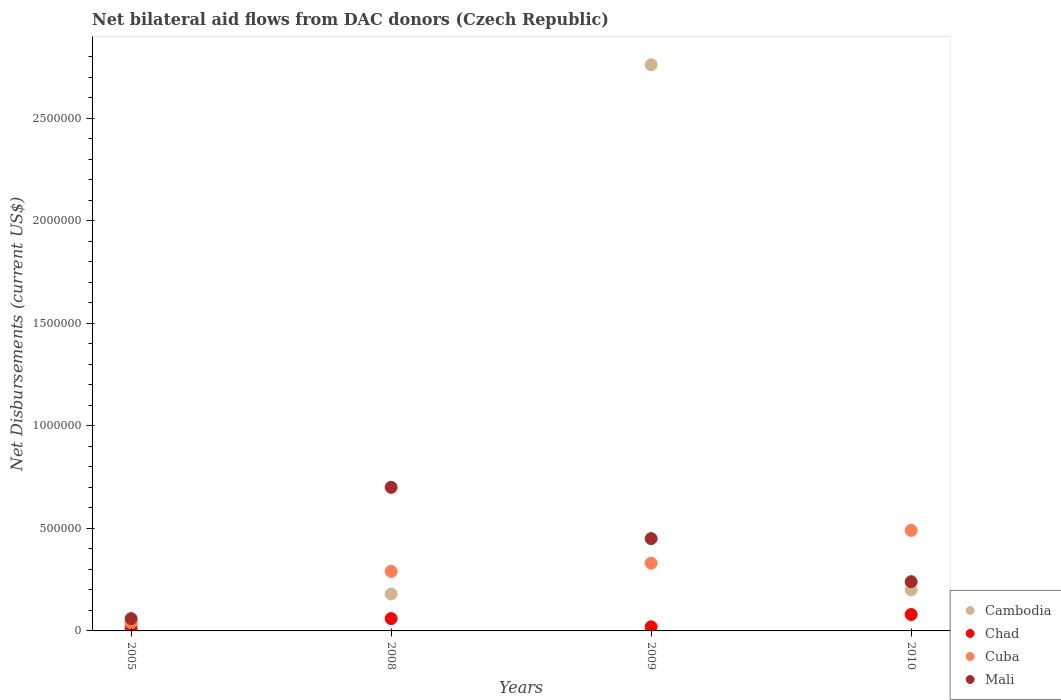Is the number of dotlines equal to the number of legend labels?
Ensure brevity in your answer.  Yes. What is the net bilateral aid flows in Mali in 2009?
Provide a short and direct response. 4.50e+05. Across all years, what is the maximum net bilateral aid flows in Cambodia?
Offer a very short reply. 2.76e+06. Across all years, what is the minimum net bilateral aid flows in Cuba?
Give a very brief answer. 4.00e+04. In which year was the net bilateral aid flows in Cambodia maximum?
Offer a very short reply. 2009. What is the total net bilateral aid flows in Chad in the graph?
Offer a terse response. 1.70e+05. What is the difference between the net bilateral aid flows in Cambodia in 2005 and that in 2009?
Provide a succinct answer. -2.73e+06. What is the difference between the net bilateral aid flows in Cuba in 2005 and the net bilateral aid flows in Cambodia in 2008?
Your response must be concise. -1.40e+05. What is the average net bilateral aid flows in Mali per year?
Offer a terse response. 3.62e+05. In the year 2005, what is the difference between the net bilateral aid flows in Chad and net bilateral aid flows in Cuba?
Provide a short and direct response. -3.00e+04. In how many years, is the net bilateral aid flows in Chad greater than 2400000 US$?
Offer a very short reply. 0. What is the ratio of the net bilateral aid flows in Chad in 2005 to that in 2008?
Give a very brief answer. 0.17. Is the net bilateral aid flows in Mali in 2005 less than that in 2009?
Your answer should be compact. Yes. Is the difference between the net bilateral aid flows in Chad in 2005 and 2010 greater than the difference between the net bilateral aid flows in Cuba in 2005 and 2010?
Offer a very short reply. Yes. What is the difference between the highest and the second highest net bilateral aid flows in Cambodia?
Provide a succinct answer. 2.56e+06. Is it the case that in every year, the sum of the net bilateral aid flows in Mali and net bilateral aid flows in Cambodia  is greater than the sum of net bilateral aid flows in Chad and net bilateral aid flows in Cuba?
Your answer should be compact. No. Does the net bilateral aid flows in Cuba monotonically increase over the years?
Give a very brief answer. Yes. Is the net bilateral aid flows in Chad strictly greater than the net bilateral aid flows in Cuba over the years?
Offer a terse response. No. How many dotlines are there?
Your response must be concise. 4. What is the difference between two consecutive major ticks on the Y-axis?
Ensure brevity in your answer.  5.00e+05. Are the values on the major ticks of Y-axis written in scientific E-notation?
Give a very brief answer. No. Does the graph contain any zero values?
Your answer should be compact. No. Where does the legend appear in the graph?
Your answer should be compact. Bottom right. How many legend labels are there?
Your answer should be very brief. 4. How are the legend labels stacked?
Give a very brief answer. Vertical. What is the title of the graph?
Ensure brevity in your answer.  Net bilateral aid flows from DAC donors (Czech Republic). Does "Argentina" appear as one of the legend labels in the graph?
Give a very brief answer. No. What is the label or title of the Y-axis?
Make the answer very short. Net Disbursements (current US$). What is the Net Disbursements (current US$) in Cambodia in 2005?
Keep it short and to the point. 3.00e+04. What is the Net Disbursements (current US$) in Cuba in 2005?
Give a very brief answer. 4.00e+04. What is the Net Disbursements (current US$) of Cambodia in 2008?
Your answer should be compact. 1.80e+05. What is the Net Disbursements (current US$) of Cambodia in 2009?
Your response must be concise. 2.76e+06. What is the Net Disbursements (current US$) of Chad in 2009?
Your response must be concise. 2.00e+04. What is the Net Disbursements (current US$) of Mali in 2009?
Your answer should be very brief. 4.50e+05. What is the Net Disbursements (current US$) in Cambodia in 2010?
Your answer should be compact. 2.00e+05. What is the Net Disbursements (current US$) in Chad in 2010?
Provide a short and direct response. 8.00e+04. What is the Net Disbursements (current US$) in Cuba in 2010?
Ensure brevity in your answer.  4.90e+05. What is the Net Disbursements (current US$) in Mali in 2010?
Offer a terse response. 2.40e+05. Across all years, what is the maximum Net Disbursements (current US$) in Cambodia?
Offer a very short reply. 2.76e+06. Across all years, what is the maximum Net Disbursements (current US$) of Cuba?
Keep it short and to the point. 4.90e+05. Across all years, what is the maximum Net Disbursements (current US$) in Mali?
Provide a succinct answer. 7.00e+05. Across all years, what is the minimum Net Disbursements (current US$) of Cuba?
Your answer should be compact. 4.00e+04. Across all years, what is the minimum Net Disbursements (current US$) of Mali?
Keep it short and to the point. 6.00e+04. What is the total Net Disbursements (current US$) in Cambodia in the graph?
Give a very brief answer. 3.17e+06. What is the total Net Disbursements (current US$) of Chad in the graph?
Your response must be concise. 1.70e+05. What is the total Net Disbursements (current US$) of Cuba in the graph?
Your response must be concise. 1.15e+06. What is the total Net Disbursements (current US$) in Mali in the graph?
Your response must be concise. 1.45e+06. What is the difference between the Net Disbursements (current US$) of Cambodia in 2005 and that in 2008?
Give a very brief answer. -1.50e+05. What is the difference between the Net Disbursements (current US$) of Chad in 2005 and that in 2008?
Make the answer very short. -5.00e+04. What is the difference between the Net Disbursements (current US$) in Cuba in 2005 and that in 2008?
Make the answer very short. -2.50e+05. What is the difference between the Net Disbursements (current US$) in Mali in 2005 and that in 2008?
Your answer should be very brief. -6.40e+05. What is the difference between the Net Disbursements (current US$) in Cambodia in 2005 and that in 2009?
Offer a very short reply. -2.73e+06. What is the difference between the Net Disbursements (current US$) of Cuba in 2005 and that in 2009?
Your answer should be compact. -2.90e+05. What is the difference between the Net Disbursements (current US$) in Mali in 2005 and that in 2009?
Make the answer very short. -3.90e+05. What is the difference between the Net Disbursements (current US$) of Cuba in 2005 and that in 2010?
Your response must be concise. -4.50e+05. What is the difference between the Net Disbursements (current US$) of Mali in 2005 and that in 2010?
Your response must be concise. -1.80e+05. What is the difference between the Net Disbursements (current US$) in Cambodia in 2008 and that in 2009?
Keep it short and to the point. -2.58e+06. What is the difference between the Net Disbursements (current US$) of Chad in 2008 and that in 2009?
Your answer should be very brief. 4.00e+04. What is the difference between the Net Disbursements (current US$) in Cuba in 2008 and that in 2009?
Make the answer very short. -4.00e+04. What is the difference between the Net Disbursements (current US$) in Chad in 2008 and that in 2010?
Ensure brevity in your answer.  -2.00e+04. What is the difference between the Net Disbursements (current US$) in Cuba in 2008 and that in 2010?
Your answer should be compact. -2.00e+05. What is the difference between the Net Disbursements (current US$) of Mali in 2008 and that in 2010?
Ensure brevity in your answer.  4.60e+05. What is the difference between the Net Disbursements (current US$) in Cambodia in 2009 and that in 2010?
Keep it short and to the point. 2.56e+06. What is the difference between the Net Disbursements (current US$) of Cuba in 2009 and that in 2010?
Offer a terse response. -1.60e+05. What is the difference between the Net Disbursements (current US$) in Mali in 2009 and that in 2010?
Offer a very short reply. 2.10e+05. What is the difference between the Net Disbursements (current US$) of Cambodia in 2005 and the Net Disbursements (current US$) of Chad in 2008?
Provide a short and direct response. -3.00e+04. What is the difference between the Net Disbursements (current US$) in Cambodia in 2005 and the Net Disbursements (current US$) in Cuba in 2008?
Give a very brief answer. -2.60e+05. What is the difference between the Net Disbursements (current US$) of Cambodia in 2005 and the Net Disbursements (current US$) of Mali in 2008?
Your response must be concise. -6.70e+05. What is the difference between the Net Disbursements (current US$) in Chad in 2005 and the Net Disbursements (current US$) in Cuba in 2008?
Provide a succinct answer. -2.80e+05. What is the difference between the Net Disbursements (current US$) in Chad in 2005 and the Net Disbursements (current US$) in Mali in 2008?
Provide a succinct answer. -6.90e+05. What is the difference between the Net Disbursements (current US$) of Cuba in 2005 and the Net Disbursements (current US$) of Mali in 2008?
Your response must be concise. -6.60e+05. What is the difference between the Net Disbursements (current US$) of Cambodia in 2005 and the Net Disbursements (current US$) of Mali in 2009?
Your answer should be very brief. -4.20e+05. What is the difference between the Net Disbursements (current US$) of Chad in 2005 and the Net Disbursements (current US$) of Cuba in 2009?
Your answer should be compact. -3.20e+05. What is the difference between the Net Disbursements (current US$) in Chad in 2005 and the Net Disbursements (current US$) in Mali in 2009?
Give a very brief answer. -4.40e+05. What is the difference between the Net Disbursements (current US$) of Cuba in 2005 and the Net Disbursements (current US$) of Mali in 2009?
Offer a terse response. -4.10e+05. What is the difference between the Net Disbursements (current US$) of Cambodia in 2005 and the Net Disbursements (current US$) of Chad in 2010?
Provide a short and direct response. -5.00e+04. What is the difference between the Net Disbursements (current US$) in Cambodia in 2005 and the Net Disbursements (current US$) in Cuba in 2010?
Make the answer very short. -4.60e+05. What is the difference between the Net Disbursements (current US$) in Chad in 2005 and the Net Disbursements (current US$) in Cuba in 2010?
Your answer should be very brief. -4.80e+05. What is the difference between the Net Disbursements (current US$) of Chad in 2005 and the Net Disbursements (current US$) of Mali in 2010?
Keep it short and to the point. -2.30e+05. What is the difference between the Net Disbursements (current US$) in Cuba in 2005 and the Net Disbursements (current US$) in Mali in 2010?
Your answer should be very brief. -2.00e+05. What is the difference between the Net Disbursements (current US$) in Cambodia in 2008 and the Net Disbursements (current US$) in Chad in 2009?
Your answer should be very brief. 1.60e+05. What is the difference between the Net Disbursements (current US$) of Cambodia in 2008 and the Net Disbursements (current US$) of Cuba in 2009?
Keep it short and to the point. -1.50e+05. What is the difference between the Net Disbursements (current US$) in Cambodia in 2008 and the Net Disbursements (current US$) in Mali in 2009?
Offer a terse response. -2.70e+05. What is the difference between the Net Disbursements (current US$) of Chad in 2008 and the Net Disbursements (current US$) of Mali in 2009?
Your response must be concise. -3.90e+05. What is the difference between the Net Disbursements (current US$) in Cambodia in 2008 and the Net Disbursements (current US$) in Cuba in 2010?
Your answer should be compact. -3.10e+05. What is the difference between the Net Disbursements (current US$) of Cambodia in 2008 and the Net Disbursements (current US$) of Mali in 2010?
Offer a terse response. -6.00e+04. What is the difference between the Net Disbursements (current US$) in Chad in 2008 and the Net Disbursements (current US$) in Cuba in 2010?
Your answer should be very brief. -4.30e+05. What is the difference between the Net Disbursements (current US$) of Cambodia in 2009 and the Net Disbursements (current US$) of Chad in 2010?
Offer a terse response. 2.68e+06. What is the difference between the Net Disbursements (current US$) in Cambodia in 2009 and the Net Disbursements (current US$) in Cuba in 2010?
Offer a terse response. 2.27e+06. What is the difference between the Net Disbursements (current US$) of Cambodia in 2009 and the Net Disbursements (current US$) of Mali in 2010?
Your response must be concise. 2.52e+06. What is the difference between the Net Disbursements (current US$) in Chad in 2009 and the Net Disbursements (current US$) in Cuba in 2010?
Your response must be concise. -4.70e+05. What is the difference between the Net Disbursements (current US$) of Cuba in 2009 and the Net Disbursements (current US$) of Mali in 2010?
Give a very brief answer. 9.00e+04. What is the average Net Disbursements (current US$) of Cambodia per year?
Keep it short and to the point. 7.92e+05. What is the average Net Disbursements (current US$) of Chad per year?
Keep it short and to the point. 4.25e+04. What is the average Net Disbursements (current US$) of Cuba per year?
Ensure brevity in your answer.  2.88e+05. What is the average Net Disbursements (current US$) in Mali per year?
Provide a short and direct response. 3.62e+05. In the year 2005, what is the difference between the Net Disbursements (current US$) of Cambodia and Net Disbursements (current US$) of Cuba?
Your answer should be compact. -10000. In the year 2005, what is the difference between the Net Disbursements (current US$) in Cambodia and Net Disbursements (current US$) in Mali?
Offer a very short reply. -3.00e+04. In the year 2005, what is the difference between the Net Disbursements (current US$) in Chad and Net Disbursements (current US$) in Cuba?
Give a very brief answer. -3.00e+04. In the year 2005, what is the difference between the Net Disbursements (current US$) of Cuba and Net Disbursements (current US$) of Mali?
Keep it short and to the point. -2.00e+04. In the year 2008, what is the difference between the Net Disbursements (current US$) of Cambodia and Net Disbursements (current US$) of Cuba?
Offer a very short reply. -1.10e+05. In the year 2008, what is the difference between the Net Disbursements (current US$) of Cambodia and Net Disbursements (current US$) of Mali?
Your answer should be very brief. -5.20e+05. In the year 2008, what is the difference between the Net Disbursements (current US$) in Chad and Net Disbursements (current US$) in Cuba?
Provide a succinct answer. -2.30e+05. In the year 2008, what is the difference between the Net Disbursements (current US$) in Chad and Net Disbursements (current US$) in Mali?
Provide a succinct answer. -6.40e+05. In the year 2008, what is the difference between the Net Disbursements (current US$) of Cuba and Net Disbursements (current US$) of Mali?
Offer a terse response. -4.10e+05. In the year 2009, what is the difference between the Net Disbursements (current US$) in Cambodia and Net Disbursements (current US$) in Chad?
Your response must be concise. 2.74e+06. In the year 2009, what is the difference between the Net Disbursements (current US$) in Cambodia and Net Disbursements (current US$) in Cuba?
Give a very brief answer. 2.43e+06. In the year 2009, what is the difference between the Net Disbursements (current US$) of Cambodia and Net Disbursements (current US$) of Mali?
Your response must be concise. 2.31e+06. In the year 2009, what is the difference between the Net Disbursements (current US$) of Chad and Net Disbursements (current US$) of Cuba?
Give a very brief answer. -3.10e+05. In the year 2009, what is the difference between the Net Disbursements (current US$) in Chad and Net Disbursements (current US$) in Mali?
Provide a succinct answer. -4.30e+05. In the year 2010, what is the difference between the Net Disbursements (current US$) in Cambodia and Net Disbursements (current US$) in Mali?
Provide a succinct answer. -4.00e+04. In the year 2010, what is the difference between the Net Disbursements (current US$) in Chad and Net Disbursements (current US$) in Cuba?
Your answer should be very brief. -4.10e+05. In the year 2010, what is the difference between the Net Disbursements (current US$) in Cuba and Net Disbursements (current US$) in Mali?
Your response must be concise. 2.50e+05. What is the ratio of the Net Disbursements (current US$) of Cambodia in 2005 to that in 2008?
Offer a very short reply. 0.17. What is the ratio of the Net Disbursements (current US$) in Chad in 2005 to that in 2008?
Provide a short and direct response. 0.17. What is the ratio of the Net Disbursements (current US$) of Cuba in 2005 to that in 2008?
Your response must be concise. 0.14. What is the ratio of the Net Disbursements (current US$) of Mali in 2005 to that in 2008?
Make the answer very short. 0.09. What is the ratio of the Net Disbursements (current US$) in Cambodia in 2005 to that in 2009?
Your answer should be compact. 0.01. What is the ratio of the Net Disbursements (current US$) in Cuba in 2005 to that in 2009?
Give a very brief answer. 0.12. What is the ratio of the Net Disbursements (current US$) of Mali in 2005 to that in 2009?
Your answer should be compact. 0.13. What is the ratio of the Net Disbursements (current US$) in Cambodia in 2005 to that in 2010?
Offer a very short reply. 0.15. What is the ratio of the Net Disbursements (current US$) of Cuba in 2005 to that in 2010?
Offer a terse response. 0.08. What is the ratio of the Net Disbursements (current US$) in Cambodia in 2008 to that in 2009?
Your answer should be compact. 0.07. What is the ratio of the Net Disbursements (current US$) of Cuba in 2008 to that in 2009?
Provide a succinct answer. 0.88. What is the ratio of the Net Disbursements (current US$) in Mali in 2008 to that in 2009?
Your answer should be compact. 1.56. What is the ratio of the Net Disbursements (current US$) of Cuba in 2008 to that in 2010?
Your answer should be compact. 0.59. What is the ratio of the Net Disbursements (current US$) in Mali in 2008 to that in 2010?
Your answer should be compact. 2.92. What is the ratio of the Net Disbursements (current US$) of Cambodia in 2009 to that in 2010?
Your response must be concise. 13.8. What is the ratio of the Net Disbursements (current US$) in Chad in 2009 to that in 2010?
Keep it short and to the point. 0.25. What is the ratio of the Net Disbursements (current US$) of Cuba in 2009 to that in 2010?
Your answer should be very brief. 0.67. What is the ratio of the Net Disbursements (current US$) in Mali in 2009 to that in 2010?
Your answer should be compact. 1.88. What is the difference between the highest and the second highest Net Disbursements (current US$) of Cambodia?
Your response must be concise. 2.56e+06. What is the difference between the highest and the second highest Net Disbursements (current US$) of Chad?
Your answer should be compact. 2.00e+04. What is the difference between the highest and the lowest Net Disbursements (current US$) of Cambodia?
Offer a terse response. 2.73e+06. What is the difference between the highest and the lowest Net Disbursements (current US$) of Chad?
Ensure brevity in your answer.  7.00e+04. What is the difference between the highest and the lowest Net Disbursements (current US$) in Mali?
Provide a succinct answer. 6.40e+05. 